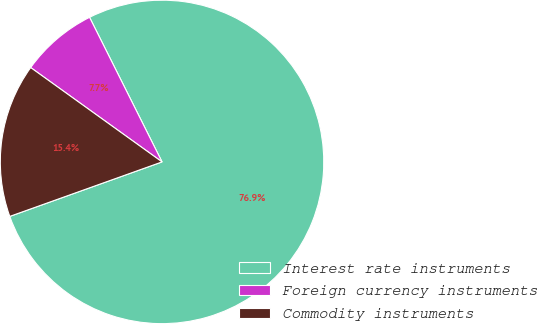Convert chart to OTSL. <chart><loc_0><loc_0><loc_500><loc_500><pie_chart><fcel>Interest rate instruments<fcel>Foreign currency instruments<fcel>Commodity instruments<nl><fcel>76.92%<fcel>7.69%<fcel>15.38%<nl></chart> 